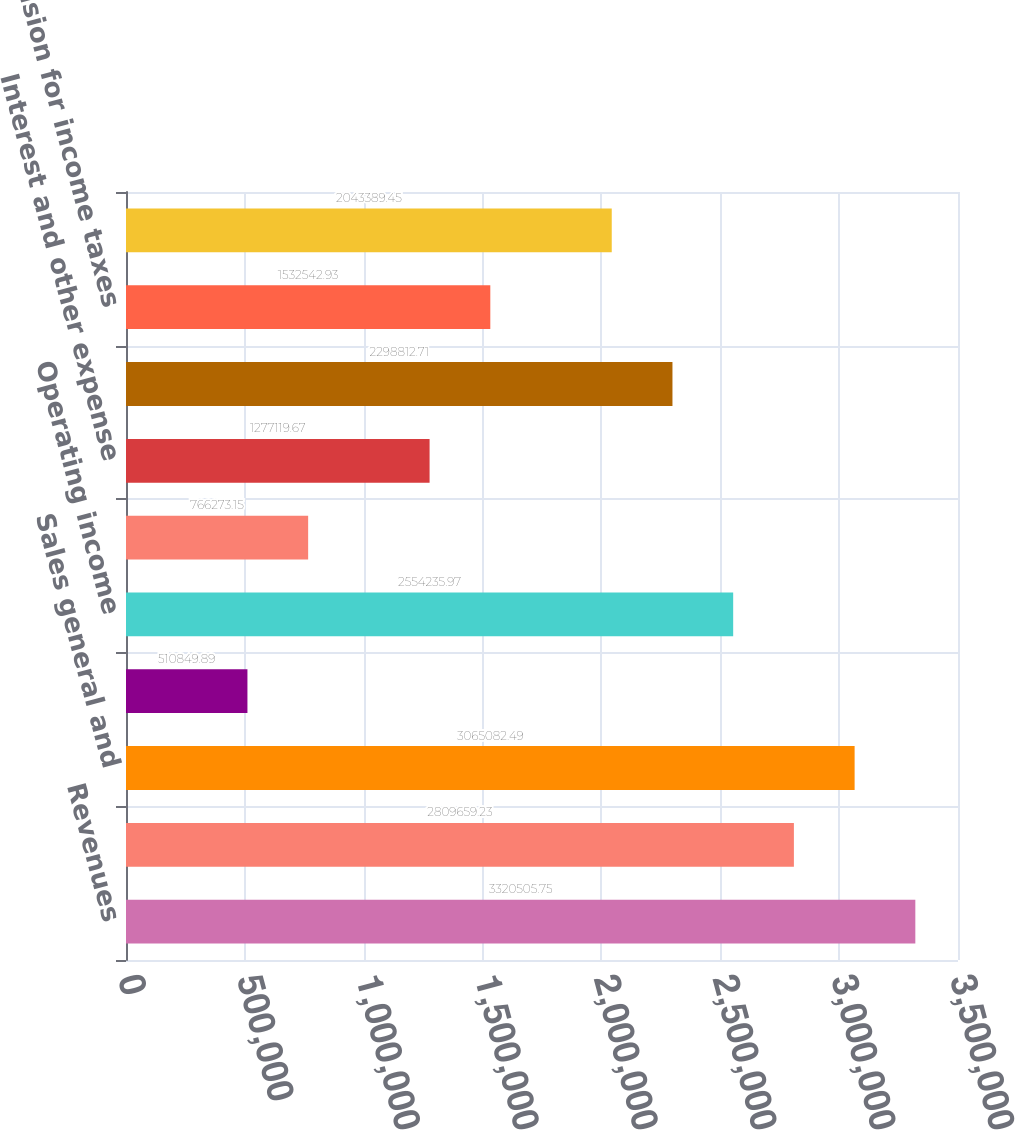<chart> <loc_0><loc_0><loc_500><loc_500><bar_chart><fcel>Revenues<fcel>Cost of service<fcel>Sales general and<fcel>Processing system intrusion<fcel>Operating income<fcel>Interest and other income<fcel>Interest and other expense<fcel>Income before income taxes<fcel>Provision for income taxes<fcel>Net income<nl><fcel>3.32051e+06<fcel>2.80966e+06<fcel>3.06508e+06<fcel>510850<fcel>2.55424e+06<fcel>766273<fcel>1.27712e+06<fcel>2.29881e+06<fcel>1.53254e+06<fcel>2.04339e+06<nl></chart> 